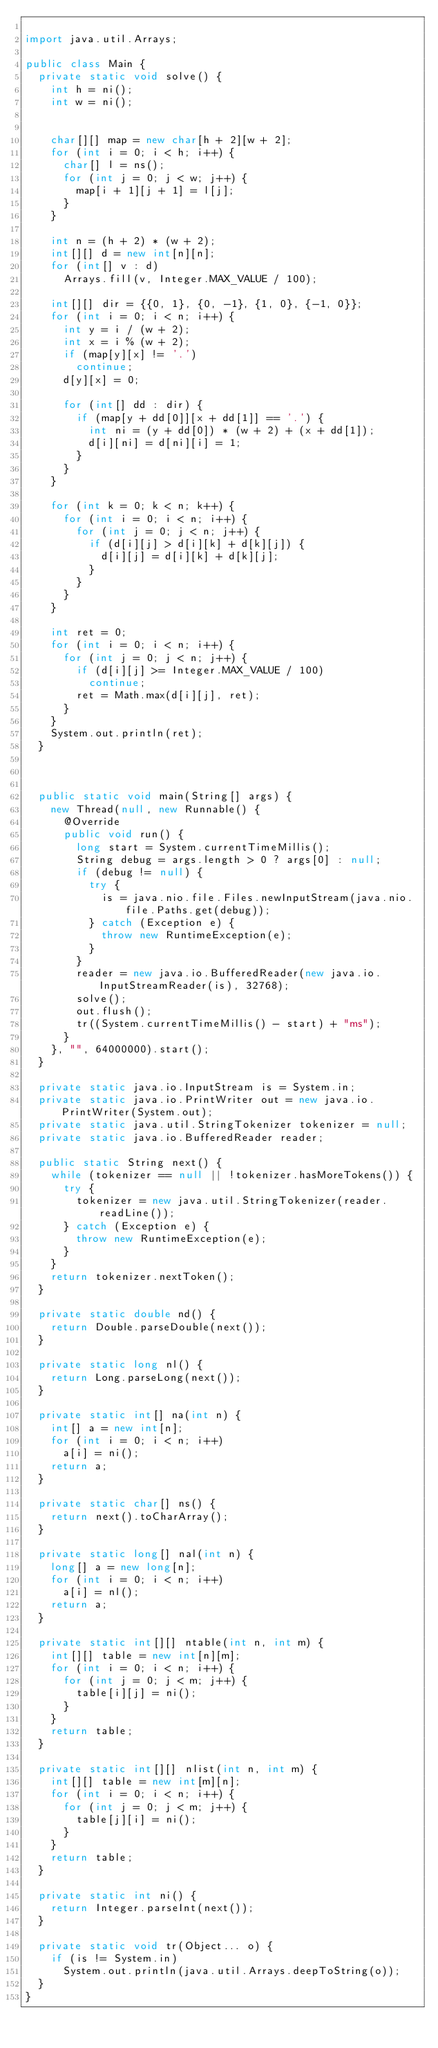<code> <loc_0><loc_0><loc_500><loc_500><_Java_>
import java.util.Arrays;

public class Main {
  private static void solve() {
    int h = ni();
    int w = ni();


    char[][] map = new char[h + 2][w + 2];
    for (int i = 0; i < h; i++) {
      char[] l = ns();
      for (int j = 0; j < w; j++) {
        map[i + 1][j + 1] = l[j];
      }
    }

    int n = (h + 2) * (w + 2);
    int[][] d = new int[n][n];
    for (int[] v : d)
      Arrays.fill(v, Integer.MAX_VALUE / 100);

    int[][] dir = {{0, 1}, {0, -1}, {1, 0}, {-1, 0}};
    for (int i = 0; i < n; i++) {
      int y = i / (w + 2);
      int x = i % (w + 2);
      if (map[y][x] != '.')
        continue;
      d[y][x] = 0;

      for (int[] dd : dir) {
        if (map[y + dd[0]][x + dd[1]] == '.') {
          int ni = (y + dd[0]) * (w + 2) + (x + dd[1]);
          d[i][ni] = d[ni][i] = 1;
        }
      }
    }

    for (int k = 0; k < n; k++) {
      for (int i = 0; i < n; i++) {
        for (int j = 0; j < n; j++) {
          if (d[i][j] > d[i][k] + d[k][j]) {
            d[i][j] = d[i][k] + d[k][j];
          }
        }
      }
    }

    int ret = 0;
    for (int i = 0; i < n; i++) {
      for (int j = 0; j < n; j++) {
        if (d[i][j] >= Integer.MAX_VALUE / 100)
          continue;
        ret = Math.max(d[i][j], ret);
      }
    }
    System.out.println(ret);
  }



  public static void main(String[] args) {
    new Thread(null, new Runnable() {
      @Override
      public void run() {
        long start = System.currentTimeMillis();
        String debug = args.length > 0 ? args[0] : null;
        if (debug != null) {
          try {
            is = java.nio.file.Files.newInputStream(java.nio.file.Paths.get(debug));
          } catch (Exception e) {
            throw new RuntimeException(e);
          }
        }
        reader = new java.io.BufferedReader(new java.io.InputStreamReader(is), 32768);
        solve();
        out.flush();
        tr((System.currentTimeMillis() - start) + "ms");
      }
    }, "", 64000000).start();
  }

  private static java.io.InputStream is = System.in;
  private static java.io.PrintWriter out = new java.io.PrintWriter(System.out);
  private static java.util.StringTokenizer tokenizer = null;
  private static java.io.BufferedReader reader;

  public static String next() {
    while (tokenizer == null || !tokenizer.hasMoreTokens()) {
      try {
        tokenizer = new java.util.StringTokenizer(reader.readLine());
      } catch (Exception e) {
        throw new RuntimeException(e);
      }
    }
    return tokenizer.nextToken();
  }

  private static double nd() {
    return Double.parseDouble(next());
  }

  private static long nl() {
    return Long.parseLong(next());
  }

  private static int[] na(int n) {
    int[] a = new int[n];
    for (int i = 0; i < n; i++)
      a[i] = ni();
    return a;
  }

  private static char[] ns() {
    return next().toCharArray();
  }

  private static long[] nal(int n) {
    long[] a = new long[n];
    for (int i = 0; i < n; i++)
      a[i] = nl();
    return a;
  }

  private static int[][] ntable(int n, int m) {
    int[][] table = new int[n][m];
    for (int i = 0; i < n; i++) {
      for (int j = 0; j < m; j++) {
        table[i][j] = ni();
      }
    }
    return table;
  }

  private static int[][] nlist(int n, int m) {
    int[][] table = new int[m][n];
    for (int i = 0; i < n; i++) {
      for (int j = 0; j < m; j++) {
        table[j][i] = ni();
      }
    }
    return table;
  }

  private static int ni() {
    return Integer.parseInt(next());
  }

  private static void tr(Object... o) {
    if (is != System.in)
      System.out.println(java.util.Arrays.deepToString(o));
  }
}
</code> 